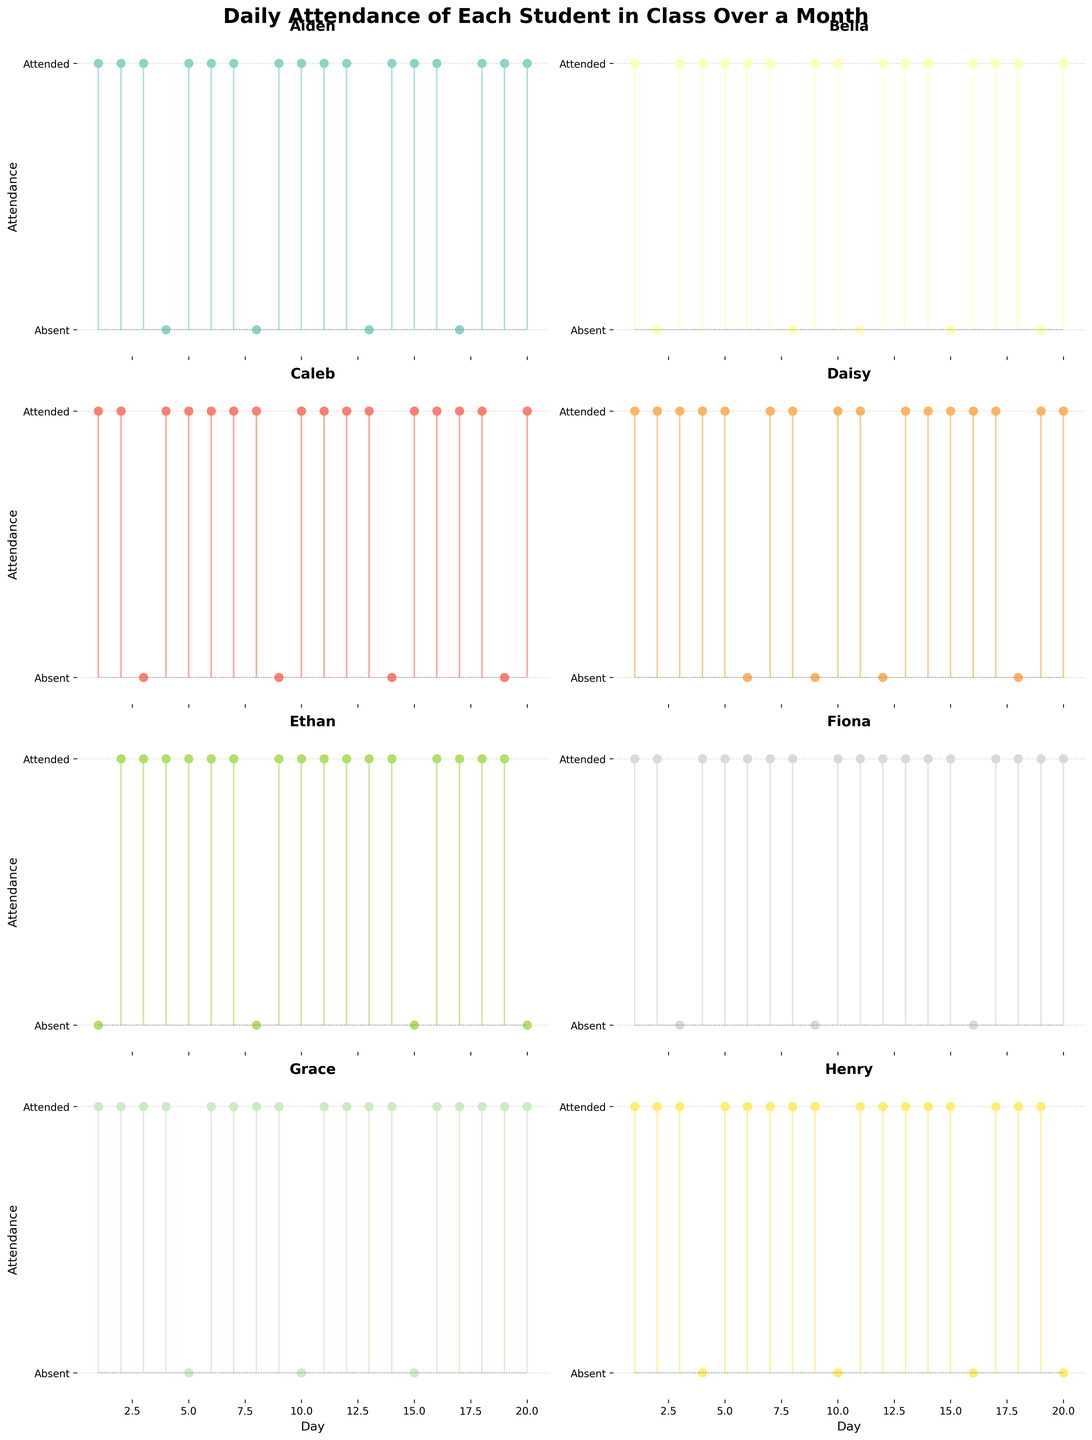How many days did Aiden attend class? Count the number of stems at the "Attended" level (value of 1) for Aiden's subplot.
Answer: 16 Which student has the highest number of absences? Identify which subplot has the most stems at the "Absent" level (value of 0).
Answer: Ethan On which days did Bella miss class? Observe Bella's subplot and identify the days where the stem is at the "Absent" level (value of 0).
Answer: Day 2, Day 8, Day 11, Day 15, Day 20 Who had fewer absences, Grace or Henry? Compare the count of stems at the "Absent" level in the subplots for Grace and Henry.
Answer: Grace How many students were absent on Day 19? Count the number of subplots with a stem at the "Absent" level on Day 19.
Answer: 3 Which student had perfect attendance for the first five days? Look at the first five stems in each subplot and find the one with no stems at the "Absent" level.
Answer: Daisy Who missed class on both Day 4 and Day 9? Check each subplot to see which has stems at "Absent" level on both Day 4 and Day 9.
Answer: Aiden, Daisy What is the average number of days attended by all students in the first 10 days? Count the attended days (value of 1) for each student in the first 10 days, sum them up, and divide by the total number of students (8).
Answer: 8.75 Who attended class for three consecutive days starting on Day 6? Look for a subplot where there are stems at the "Attended" level for Day 6, Day 7, and Day 8.
Answer: Bella, Daisy, Grace, Fiona 